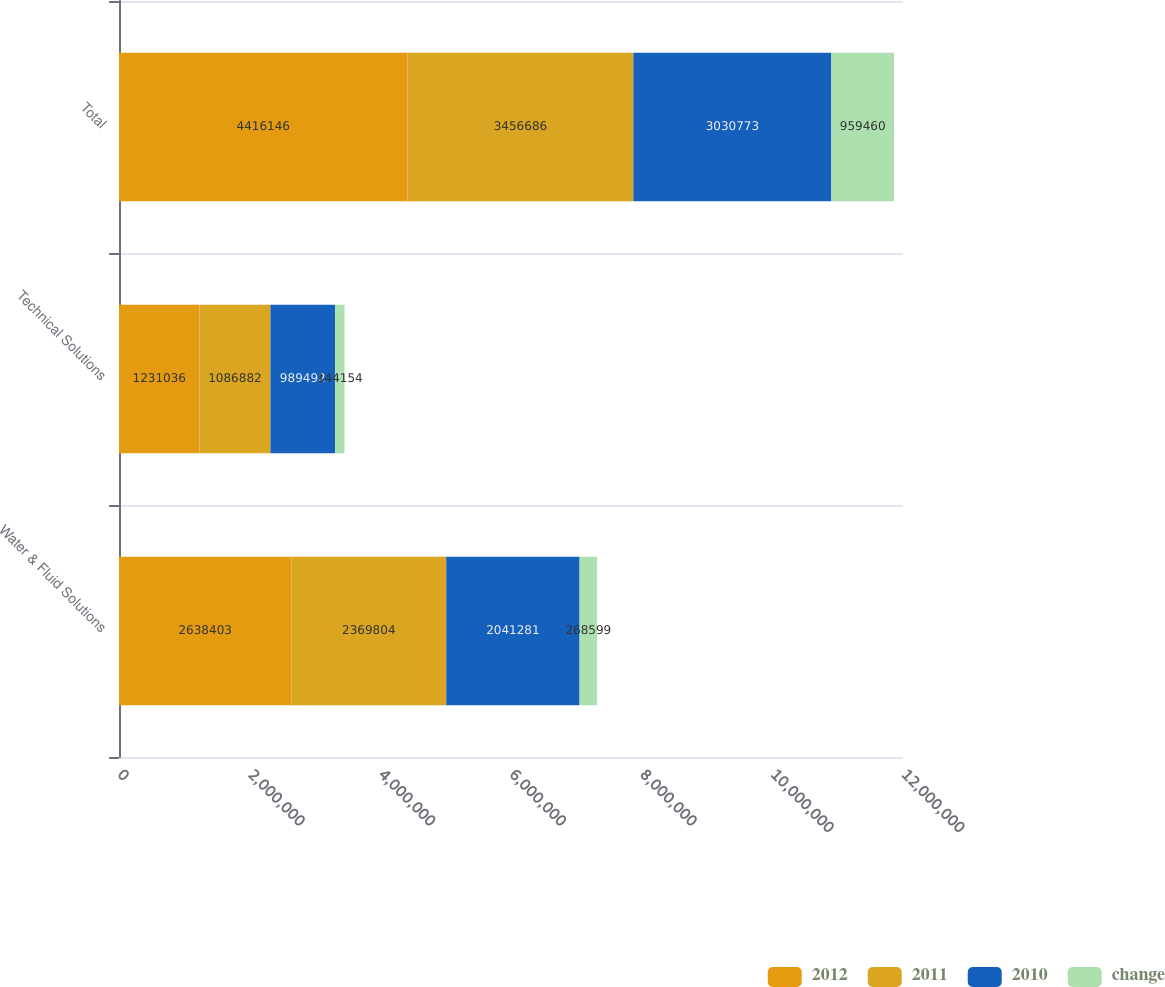<chart> <loc_0><loc_0><loc_500><loc_500><stacked_bar_chart><ecel><fcel>Water & Fluid Solutions<fcel>Technical Solutions<fcel>Total<nl><fcel>2012<fcel>2.6384e+06<fcel>1.23104e+06<fcel>4.41615e+06<nl><fcel>2011<fcel>2.3698e+06<fcel>1.08688e+06<fcel>3.45669e+06<nl><fcel>2010<fcel>2.04128e+06<fcel>989492<fcel>3.03077e+06<nl><fcel>change<fcel>268599<fcel>144154<fcel>959460<nl></chart> 